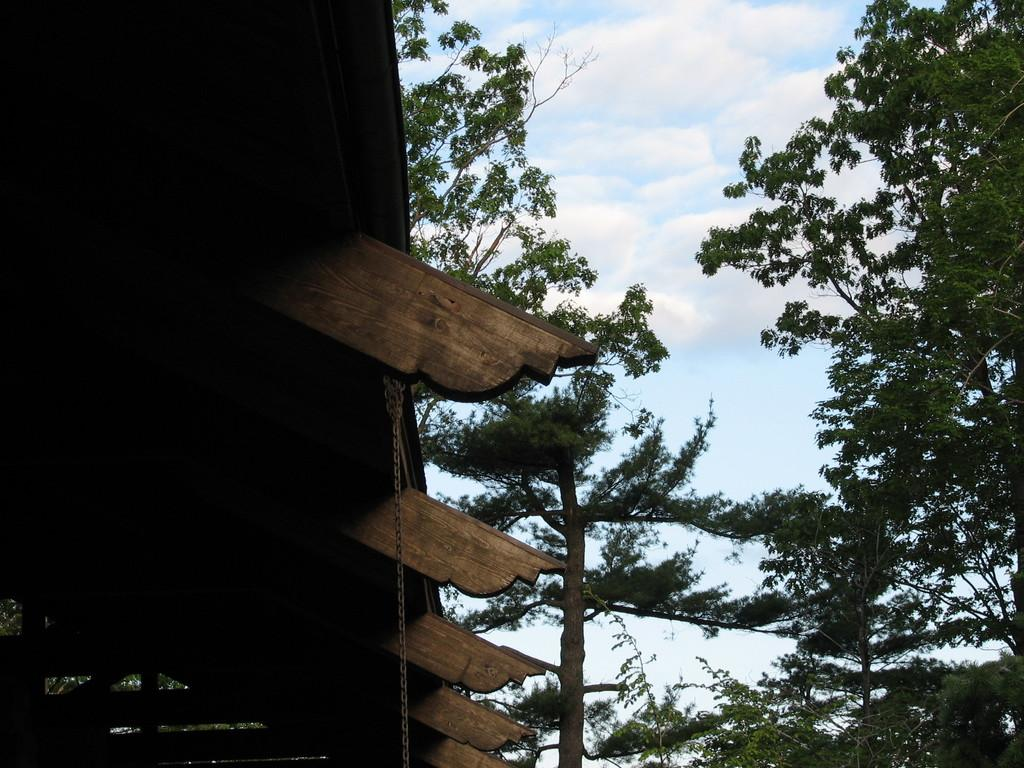What type of vegetation is on the right side of the image? There are trees on the right side of the image. What type of structure is on the left side of the image? There is a wooden roof on the left side of the image. What type of channel can be seen in the image? There is no channel present in the image. Is there a throne visible in the image? There is no throne present in the image. 